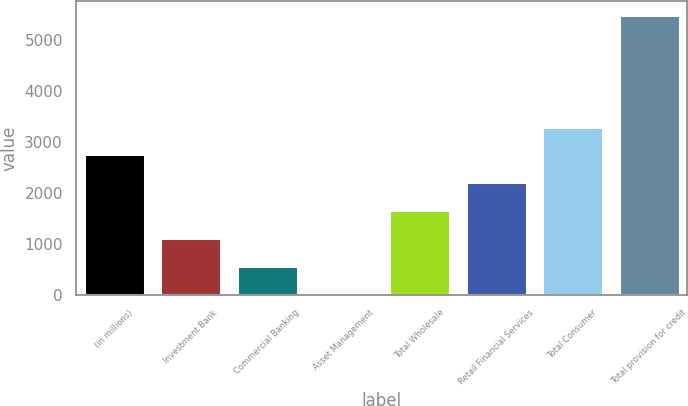Convert chart. <chart><loc_0><loc_0><loc_500><loc_500><bar_chart><fcel>(in millions)<fcel>Investment Bank<fcel>Commercial Banking<fcel>Asset Management<fcel>Total Wholesale<fcel>Retail Financial Services<fcel>Total Consumer<fcel>Total provision for credit<nl><fcel>2754<fcel>1118.4<fcel>573.2<fcel>28<fcel>1663.6<fcel>2208.8<fcel>3299.2<fcel>5480<nl></chart> 